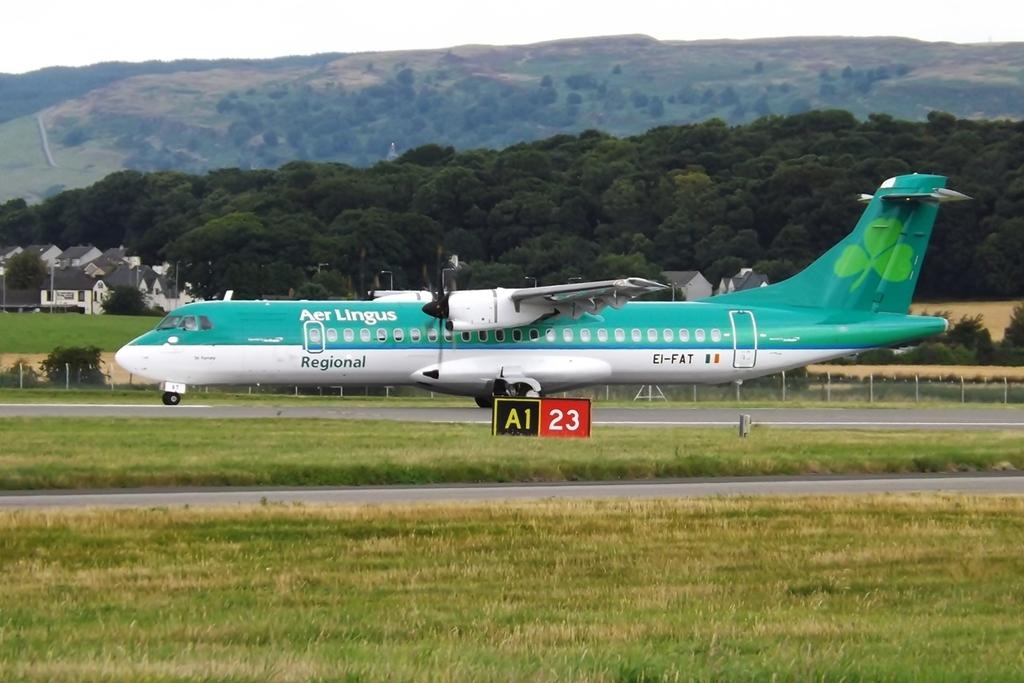<image>
Provide a brief description of the given image. An Aer Lingus airplane is on runway A1 23. 